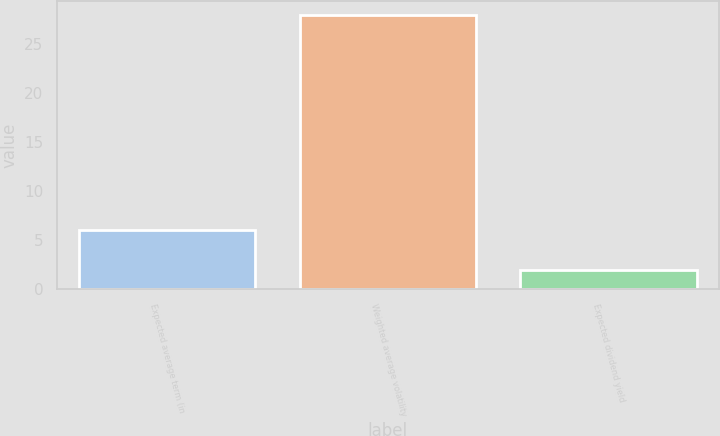Convert chart. <chart><loc_0><loc_0><loc_500><loc_500><bar_chart><fcel>Expected average term (in<fcel>Weighted average volatility<fcel>Expected dividend yield<nl><fcel>6<fcel>28<fcel>2<nl></chart> 